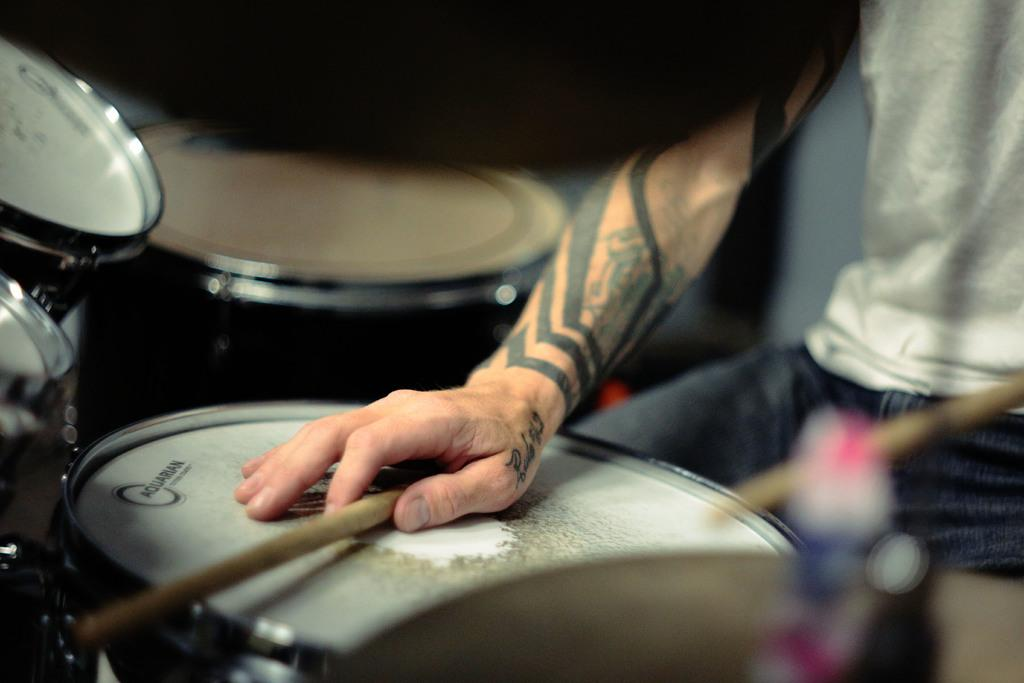What objects are present in the image? There are musical instruments in the image. Can you describe the person in the image? There is a person on the right side of the image. What is the person holding in his hand? The person is holding a stick in his hand. What type of tail can be seen on the musical instruments in the image? There are no tails present on the musical instruments in the image. What kind of thing is the person trying to fix with the stick in the image? There is no indication in the image that the person is trying to fix anything with the stick. 